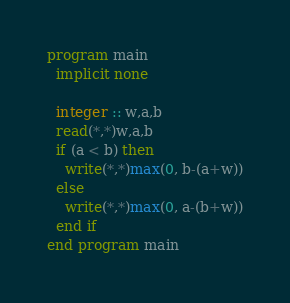Convert code to text. <code><loc_0><loc_0><loc_500><loc_500><_FORTRAN_>program main
  implicit none
  
  integer :: w,a,b
  read(*,*)w,a,b
  if (a < b) then
    write(*,*)max(0, b-(a+w))
  else
    write(*,*)max(0, a-(b+w))
  end if
end program main</code> 